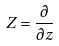<formula> <loc_0><loc_0><loc_500><loc_500>Z = \frac { \partial } { \partial z }</formula> 